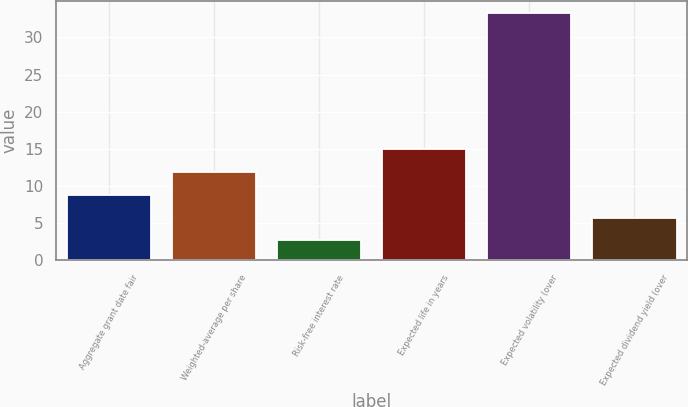Convert chart to OTSL. <chart><loc_0><loc_0><loc_500><loc_500><bar_chart><fcel>Aggregate grant date fair<fcel>Weighted-average per share<fcel>Risk-free interest rate<fcel>Expected life in years<fcel>Expected volatility (over<fcel>Expected dividend yield (over<nl><fcel>8.82<fcel>11.88<fcel>2.7<fcel>14.94<fcel>33.3<fcel>5.76<nl></chart> 